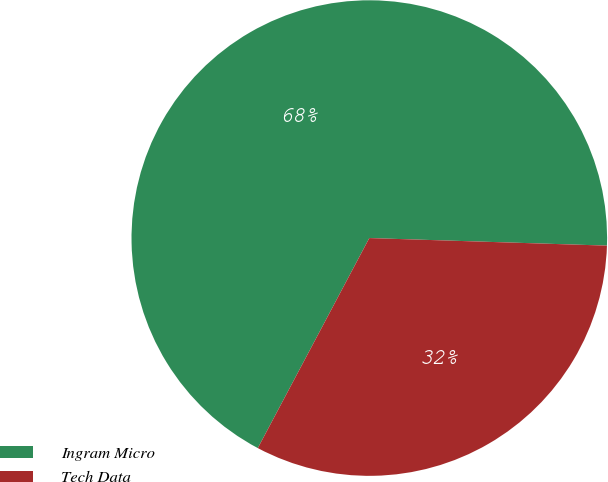Convert chart to OTSL. <chart><loc_0><loc_0><loc_500><loc_500><pie_chart><fcel>Ingram Micro<fcel>Tech Data<nl><fcel>67.74%<fcel>32.26%<nl></chart> 